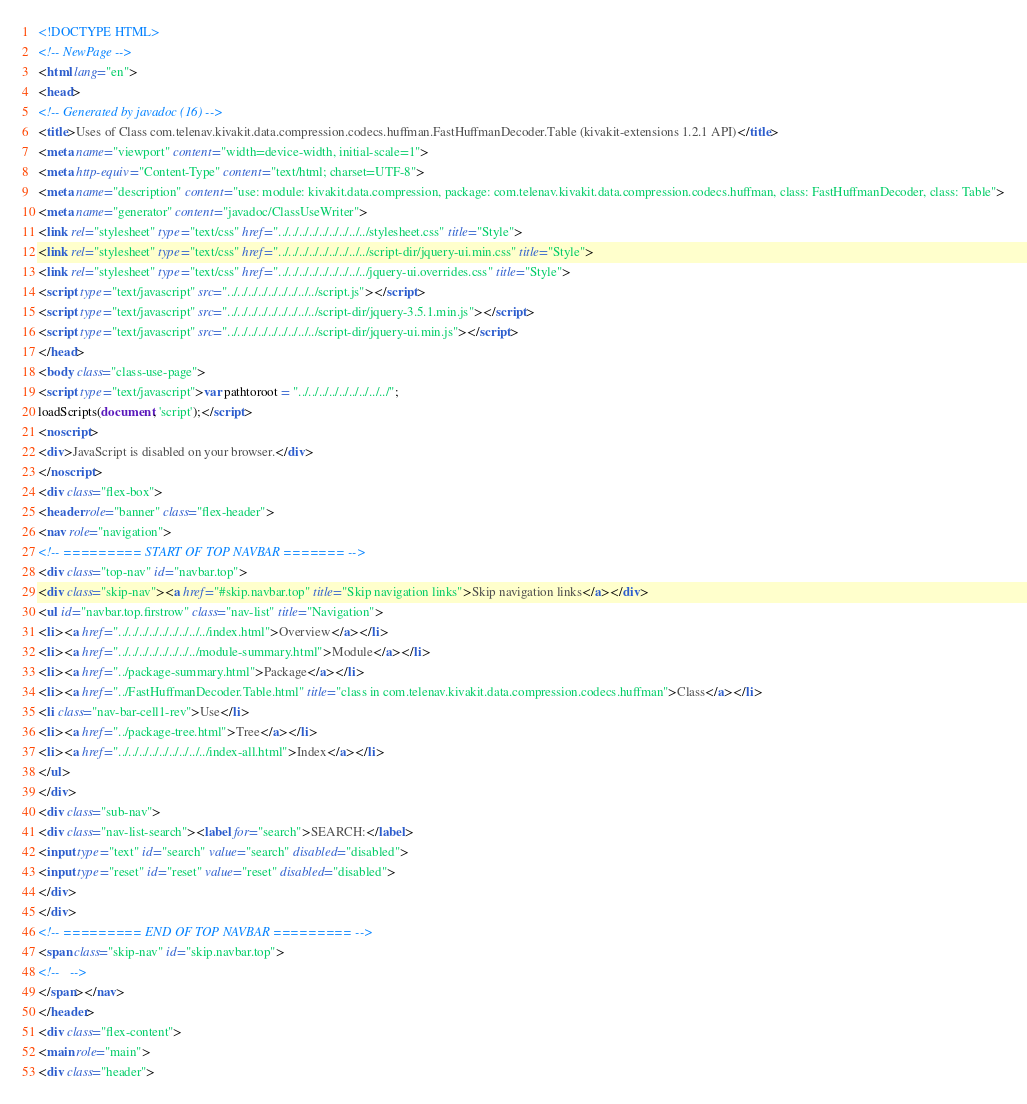Convert code to text. <code><loc_0><loc_0><loc_500><loc_500><_HTML_><!DOCTYPE HTML>
<!-- NewPage -->
<html lang="en">
<head>
<!-- Generated by javadoc (16) -->
<title>Uses of Class com.telenav.kivakit.data.compression.codecs.huffman.FastHuffmanDecoder.Table (kivakit-extensions 1.2.1 API)</title>
<meta name="viewport" content="width=device-width, initial-scale=1">
<meta http-equiv="Content-Type" content="text/html; charset=UTF-8">
<meta name="description" content="use: module: kivakit.data.compression, package: com.telenav.kivakit.data.compression.codecs.huffman, class: FastHuffmanDecoder, class: Table">
<meta name="generator" content="javadoc/ClassUseWriter">
<link rel="stylesheet" type="text/css" href="../../../../../../../../../stylesheet.css" title="Style">
<link rel="stylesheet" type="text/css" href="../../../../../../../../../script-dir/jquery-ui.min.css" title="Style">
<link rel="stylesheet" type="text/css" href="../../../../../../../../../jquery-ui.overrides.css" title="Style">
<script type="text/javascript" src="../../../../../../../../../script.js"></script>
<script type="text/javascript" src="../../../../../../../../../script-dir/jquery-3.5.1.min.js"></script>
<script type="text/javascript" src="../../../../../../../../../script-dir/jquery-ui.min.js"></script>
</head>
<body class="class-use-page">
<script type="text/javascript">var pathtoroot = "../../../../../../../../../";
loadScripts(document, 'script');</script>
<noscript>
<div>JavaScript is disabled on your browser.</div>
</noscript>
<div class="flex-box">
<header role="banner" class="flex-header">
<nav role="navigation">
<!-- ========= START OF TOP NAVBAR ======= -->
<div class="top-nav" id="navbar.top">
<div class="skip-nav"><a href="#skip.navbar.top" title="Skip navigation links">Skip navigation links</a></div>
<ul id="navbar.top.firstrow" class="nav-list" title="Navigation">
<li><a href="../../../../../../../../../index.html">Overview</a></li>
<li><a href="../../../../../../../../module-summary.html">Module</a></li>
<li><a href="../package-summary.html">Package</a></li>
<li><a href="../FastHuffmanDecoder.Table.html" title="class in com.telenav.kivakit.data.compression.codecs.huffman">Class</a></li>
<li class="nav-bar-cell1-rev">Use</li>
<li><a href="../package-tree.html">Tree</a></li>
<li><a href="../../../../../../../../../index-all.html">Index</a></li>
</ul>
</div>
<div class="sub-nav">
<div class="nav-list-search"><label for="search">SEARCH:</label>
<input type="text" id="search" value="search" disabled="disabled">
<input type="reset" id="reset" value="reset" disabled="disabled">
</div>
</div>
<!-- ========= END OF TOP NAVBAR ========= -->
<span class="skip-nav" id="skip.navbar.top">
<!--   -->
</span></nav>
</header>
<div class="flex-content">
<main role="main">
<div class="header"></code> 